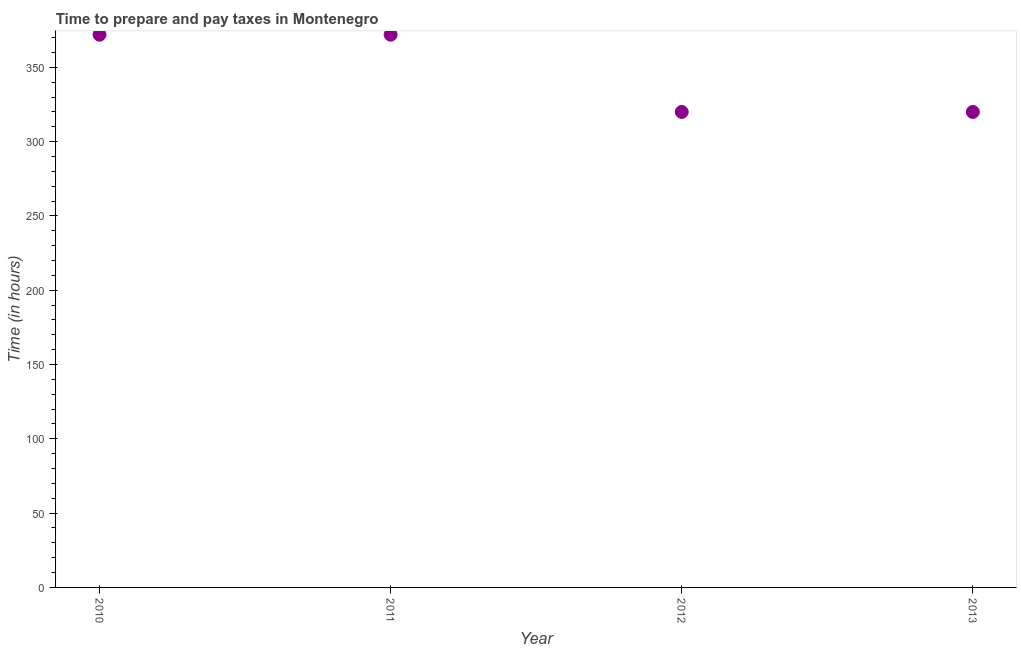What is the time to prepare and pay taxes in 2013?
Offer a terse response. 320. Across all years, what is the maximum time to prepare and pay taxes?
Your response must be concise. 372. Across all years, what is the minimum time to prepare and pay taxes?
Your answer should be compact. 320. What is the sum of the time to prepare and pay taxes?
Give a very brief answer. 1384. What is the average time to prepare and pay taxes per year?
Offer a very short reply. 346. What is the median time to prepare and pay taxes?
Make the answer very short. 346. In how many years, is the time to prepare and pay taxes greater than 280 hours?
Your answer should be compact. 4. What is the ratio of the time to prepare and pay taxes in 2011 to that in 2013?
Provide a short and direct response. 1.16. What is the difference between the highest and the second highest time to prepare and pay taxes?
Give a very brief answer. 0. What is the difference between the highest and the lowest time to prepare and pay taxes?
Keep it short and to the point. 52. In how many years, is the time to prepare and pay taxes greater than the average time to prepare and pay taxes taken over all years?
Ensure brevity in your answer.  2. Does the time to prepare and pay taxes monotonically increase over the years?
Ensure brevity in your answer.  No. How many years are there in the graph?
Provide a succinct answer. 4. What is the difference between two consecutive major ticks on the Y-axis?
Your response must be concise. 50. Does the graph contain any zero values?
Make the answer very short. No. What is the title of the graph?
Offer a terse response. Time to prepare and pay taxes in Montenegro. What is the label or title of the X-axis?
Provide a short and direct response. Year. What is the label or title of the Y-axis?
Your response must be concise. Time (in hours). What is the Time (in hours) in 2010?
Ensure brevity in your answer.  372. What is the Time (in hours) in 2011?
Keep it short and to the point. 372. What is the Time (in hours) in 2012?
Your answer should be compact. 320. What is the Time (in hours) in 2013?
Your answer should be very brief. 320. What is the difference between the Time (in hours) in 2010 and 2011?
Your response must be concise. 0. What is the difference between the Time (in hours) in 2010 and 2013?
Make the answer very short. 52. What is the difference between the Time (in hours) in 2012 and 2013?
Offer a very short reply. 0. What is the ratio of the Time (in hours) in 2010 to that in 2012?
Your answer should be very brief. 1.16. What is the ratio of the Time (in hours) in 2010 to that in 2013?
Provide a succinct answer. 1.16. What is the ratio of the Time (in hours) in 2011 to that in 2012?
Keep it short and to the point. 1.16. What is the ratio of the Time (in hours) in 2011 to that in 2013?
Give a very brief answer. 1.16. What is the ratio of the Time (in hours) in 2012 to that in 2013?
Your answer should be compact. 1. 